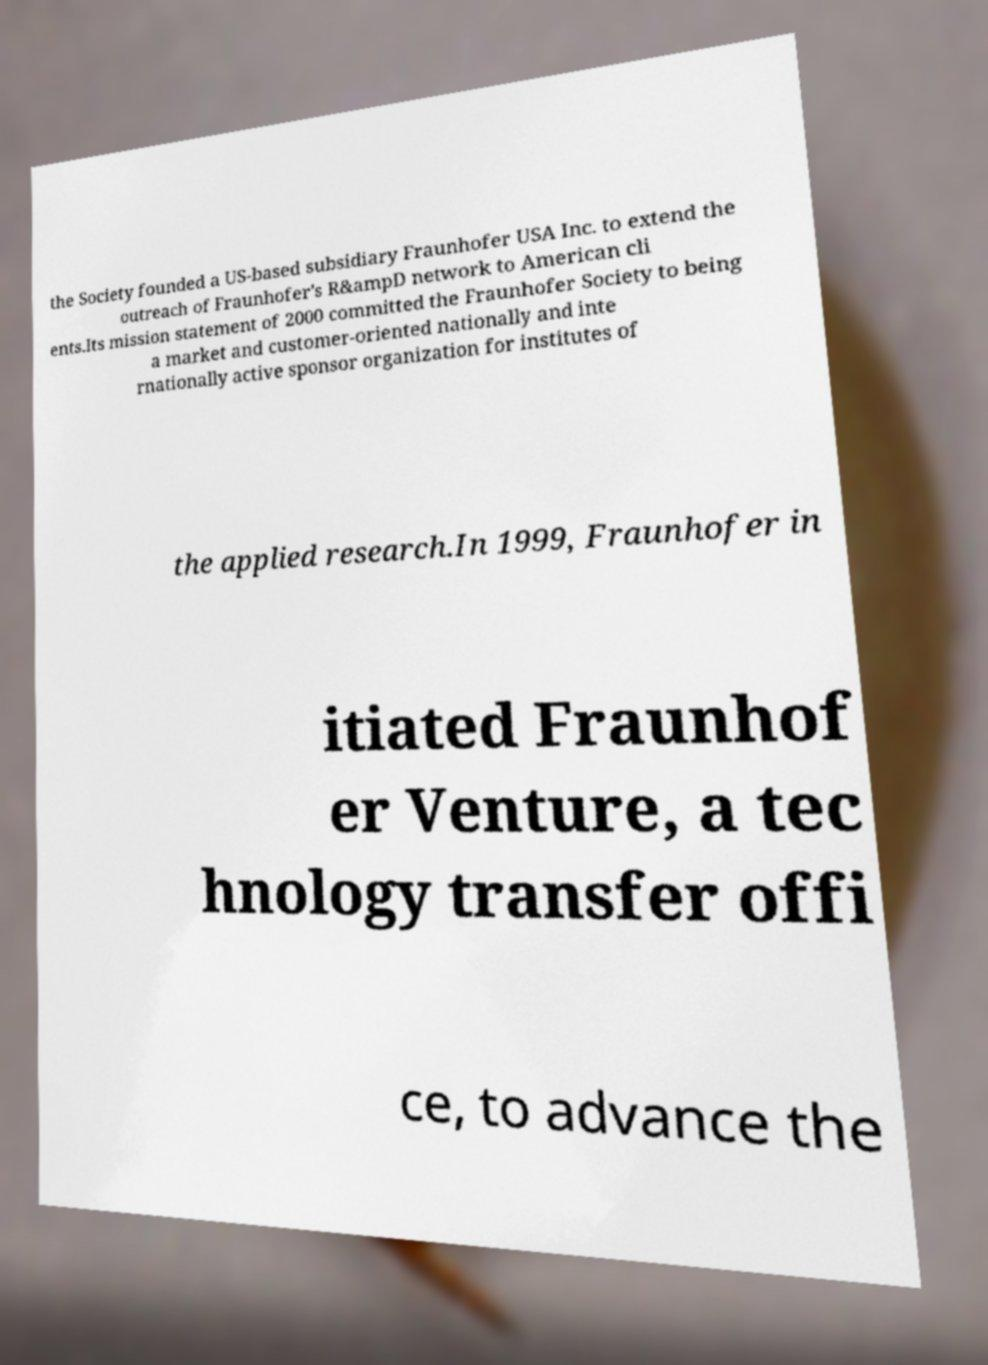There's text embedded in this image that I need extracted. Can you transcribe it verbatim? the Society founded a US-based subsidiary Fraunhofer USA Inc. to extend the outreach of Fraunhofer's R&ampD network to American cli ents.Its mission statement of 2000 committed the Fraunhofer Society to being a market and customer-oriented nationally and inte rnationally active sponsor organization for institutes of the applied research.In 1999, Fraunhofer in itiated Fraunhof er Venture, a tec hnology transfer offi ce, to advance the 